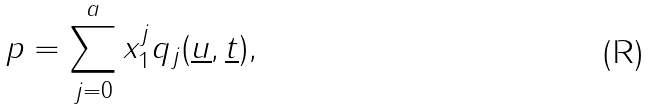<formula> <loc_0><loc_0><loc_500><loc_500>p = \sum _ { j = 0 } ^ { a } { x _ { 1 } ^ { j } q _ { j } ( \underline { u } , \underline { t } ) } ,</formula> 